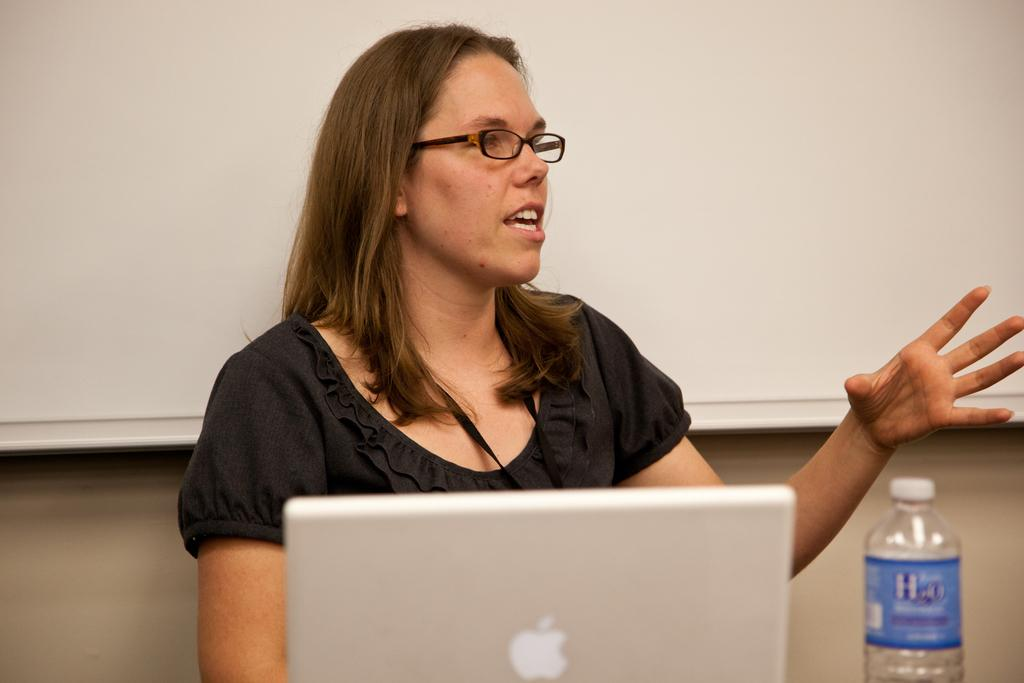Who is the main subject in the image? There is a woman in the image. What object is in front of the woman? There is a laptop and a bottle in front of the woman. Is there any indication of a whiteboard in the image? There may be a whiteboard on the wall behind the woman. What type of crime is being committed in the image? There is no indication of a crime being committed in the image. The image features a woman with a laptop and a bottle in front of her, and possibly a whiteboard on the wall behind her. 